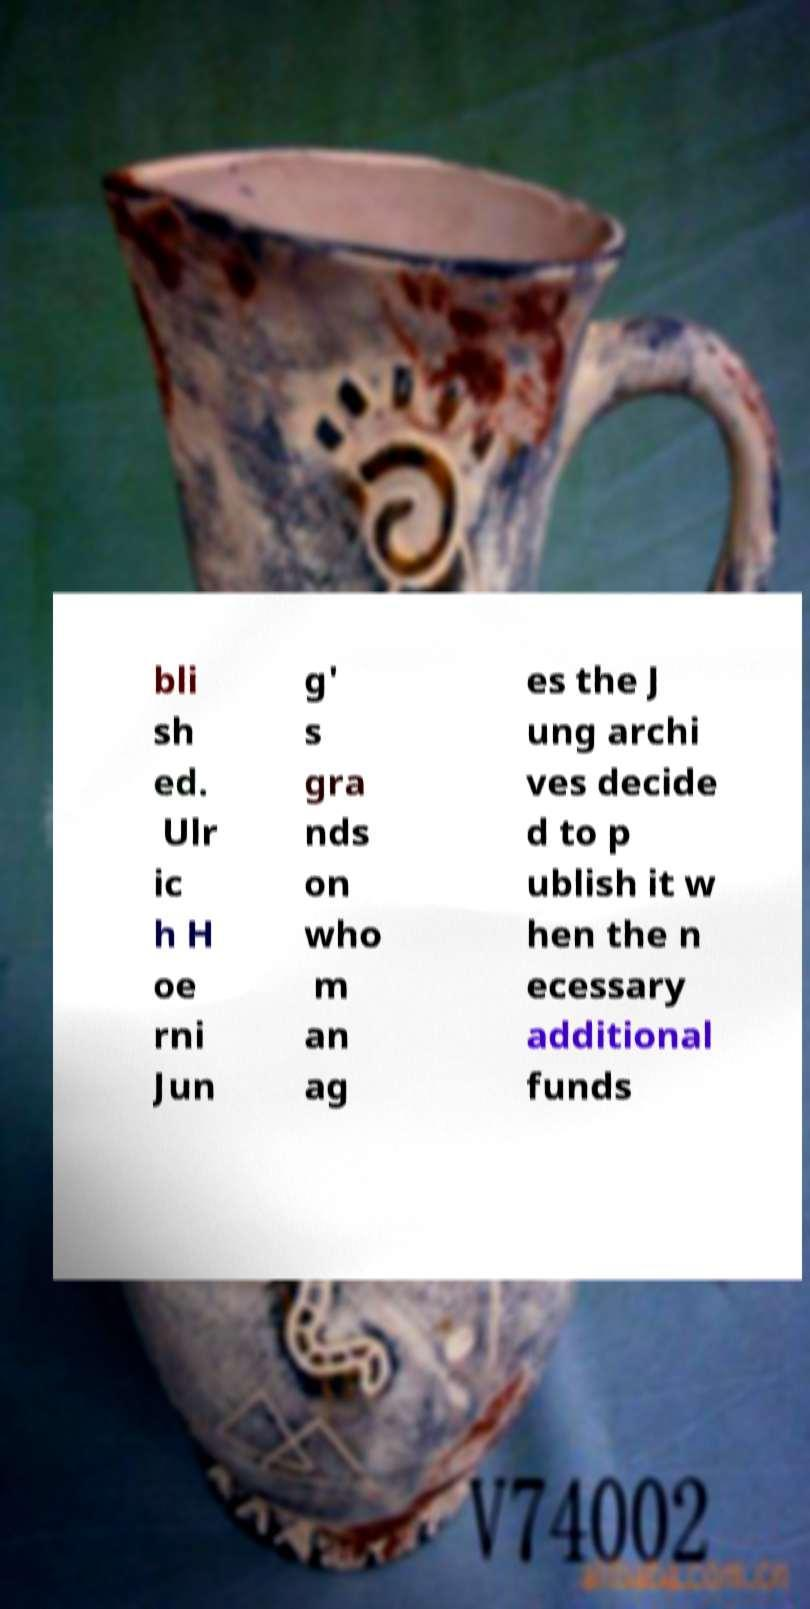Could you extract and type out the text from this image? bli sh ed. Ulr ic h H oe rni Jun g' s gra nds on who m an ag es the J ung archi ves decide d to p ublish it w hen the n ecessary additional funds 